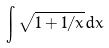<formula> <loc_0><loc_0><loc_500><loc_500>\int \sqrt { 1 + 1 / x } d x</formula> 